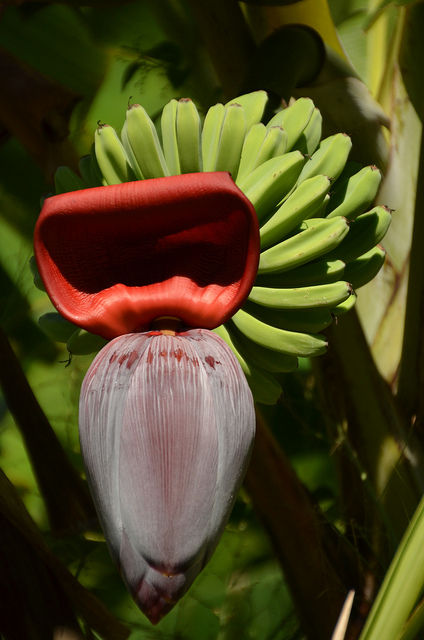<image>Is this plant edible? I don't know if the plant is edible. It could be either edible or non-edible. Is this plant edible? I don't know if this plant is edible. It can be both edible and non-edible. 